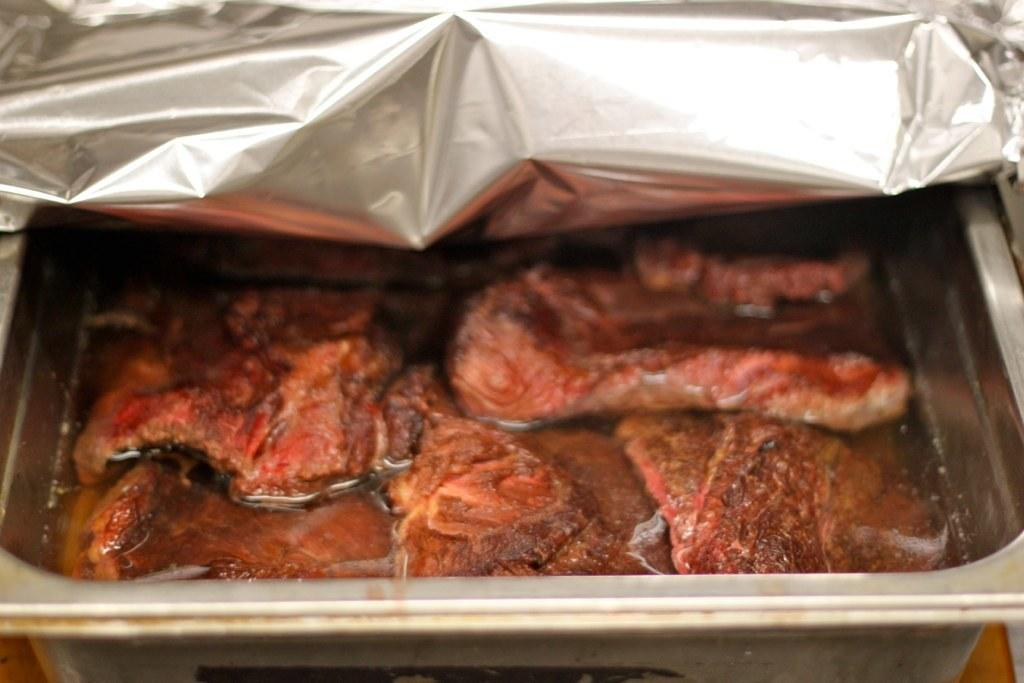What is the main subject of the image? There is a food item in the image. How is the food item presented in the image? The food item is in a tray. Is there any additional material covering the food item? Yes, there is a part of silver paper on top of the tray. What channel is the cats watching in the image? There are no cats or television in the image, so it is not possible to determine what channel they might be watching. 